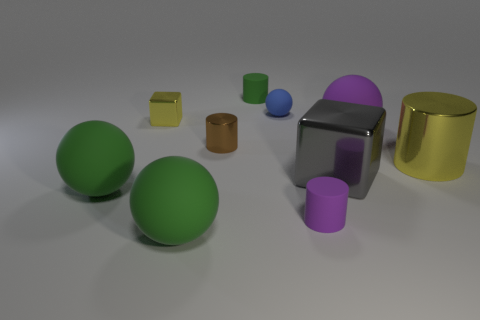How many cylinders are present in the image and what are their colors? There are two cylinders visible in the image. One cylinder is blue and is located in front of the large gray metal block. The other cylinder is brown and is resting on the far left side of the image. Are they the same size and if not, how do they differ? They are not the same size. The blue cylinder is taller and narrower, while the brown cylinder is shorter and wider. Each cylinder has a distinct size, contributing to the variety of shapes in the composition. 